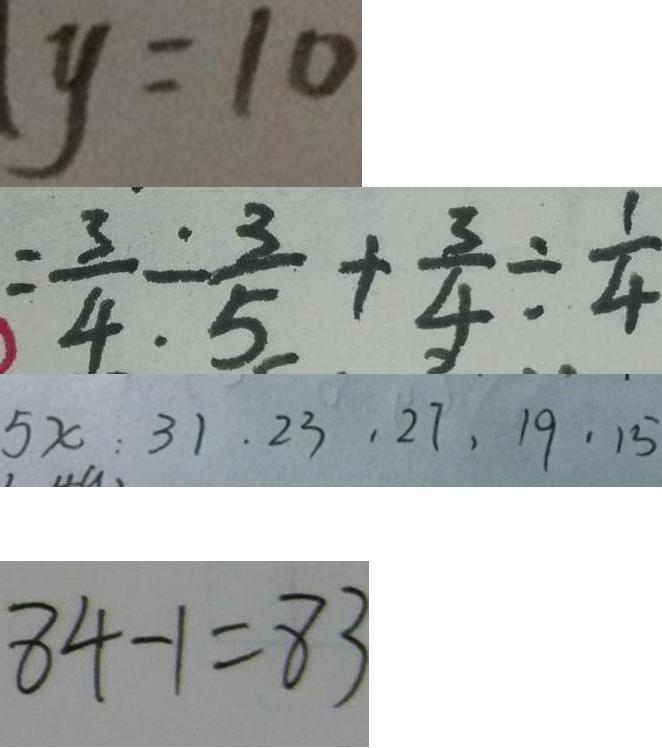Convert formula to latex. <formula><loc_0><loc_0><loc_500><loc_500>y = 1 0 
 = \frac { 3 } { 4 } \div \frac { 3 } { 5 } + \frac { 3 } { 4 } \div \frac { 1 } { 4 } 
 5 x : 3 1 . 2 3 , 2 7 , 1 9 , 1 5 
 8 4 - 1 = 8 3</formula> 